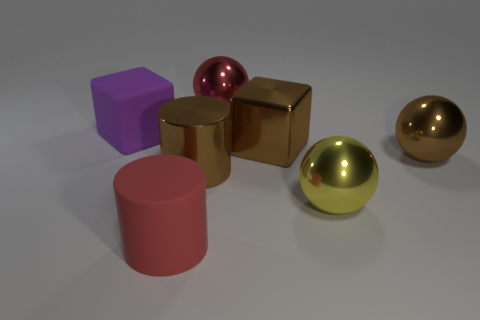There is a big brown thing that is the same shape as the large purple thing; what is it made of?
Your response must be concise. Metal. Is the color of the large matte cylinder the same as the large ball behind the purple rubber block?
Give a very brief answer. Yes. What is the material of the large red thing that is behind the large metallic cylinder?
Provide a succinct answer. Metal. What is the shape of the thing that is the same color as the big rubber cylinder?
Ensure brevity in your answer.  Sphere. The yellow ball that is the same material as the brown cube is what size?
Your answer should be very brief. Large. Is the number of rubber blocks less than the number of gray shiny cylinders?
Make the answer very short. No. What number of big things are red rubber things or brown metallic things?
Make the answer very short. 4. How many things are both in front of the brown cube and to the left of the big brown block?
Offer a terse response. 2. Are there more big brown shiny objects than big cylinders?
Provide a short and direct response. Yes. What number of other things are the same shape as the red metallic thing?
Offer a terse response. 2. 